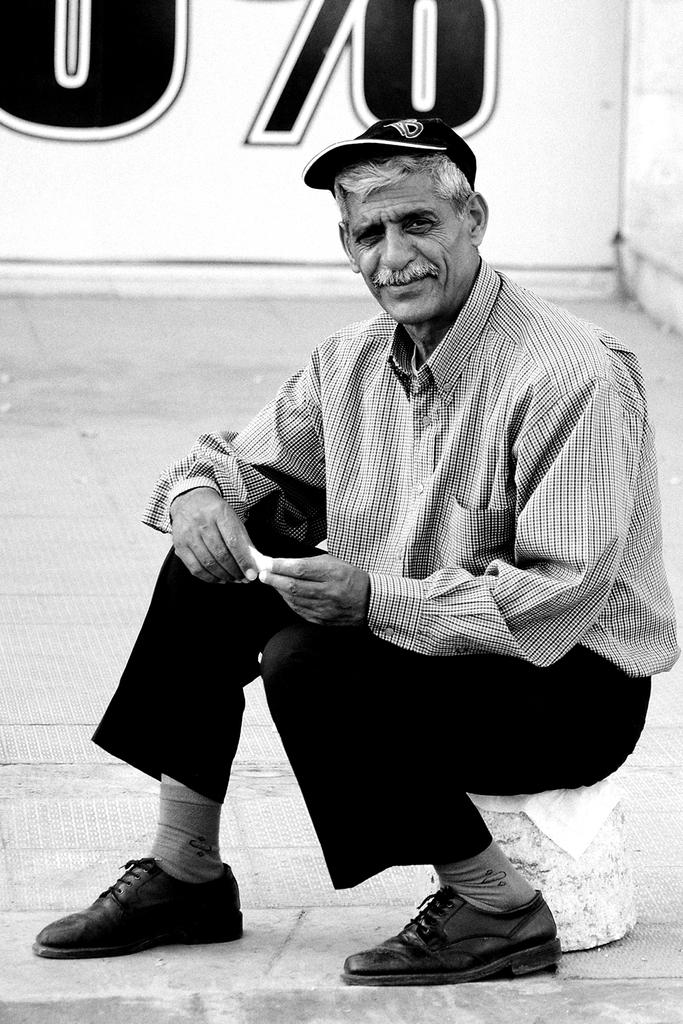Who is the main subject in the image? There is an old man in the image. What is the old man doing in the image? The old man is sitting on a stone. What is the old man wearing on his head? The old man is wearing a cap. What can be seen in the background of the image? There is a wall in the background of the image. What type of ink is the old man using to write on the stone? There is no ink or writing present in the image; the old man is simply sitting on the stone. 